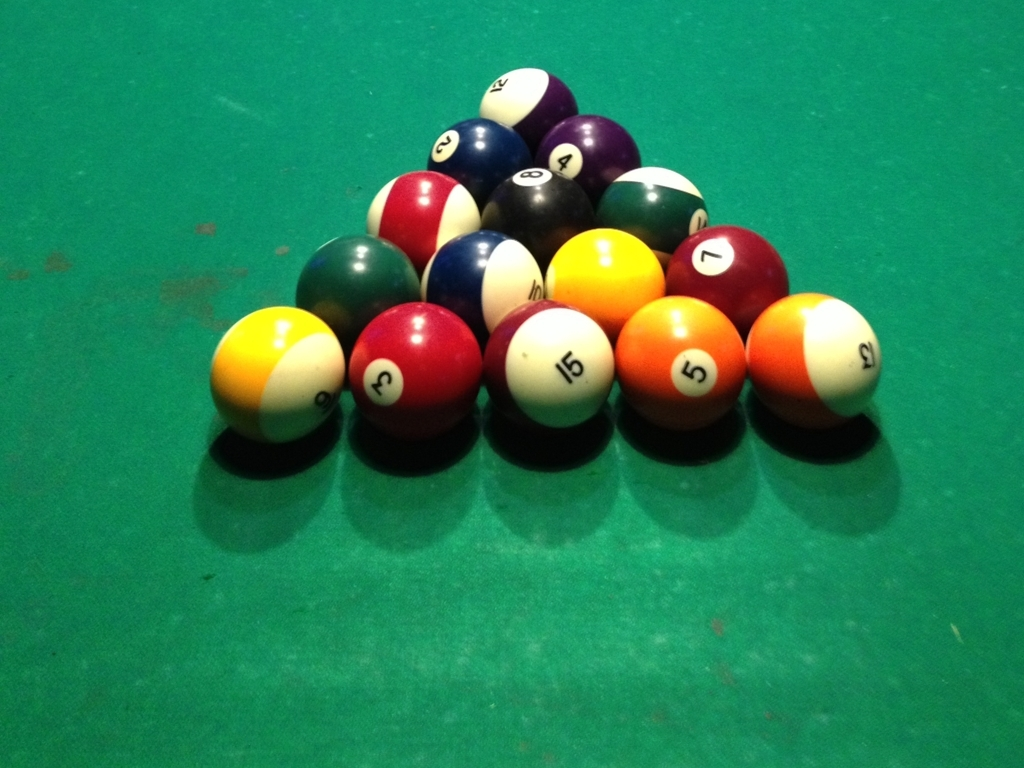Why is the composition of the image described as slightly messy? The composition of the image can be described as slightly messy due to the arrangement of billiard balls clustered on the table. While each ball is distinct and the details are clear, there is no apparent order or alignment, giving a sense of disorganization. This contrasts with a setting where balls would be meticulously arranged for a game, which would exhibit a more organized and aesthetically pleasing composition. 